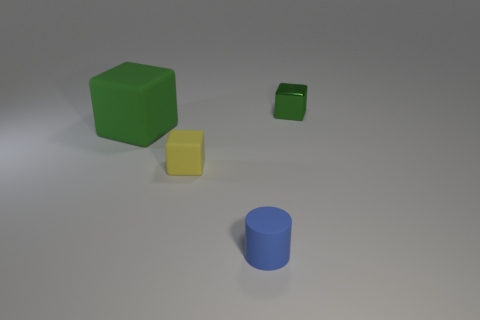Subtract all tiny shiny cubes. How many cubes are left? 2 Add 3 small brown cylinders. How many objects exist? 7 Subtract 0 cyan blocks. How many objects are left? 4 Subtract all blocks. How many objects are left? 1 Subtract 1 blocks. How many blocks are left? 2 Subtract all green blocks. Subtract all blue cylinders. How many blocks are left? 1 Subtract all purple spheres. How many green blocks are left? 2 Subtract all big things. Subtract all tiny red metallic spheres. How many objects are left? 3 Add 4 tiny rubber blocks. How many tiny rubber blocks are left? 5 Add 2 brown things. How many brown things exist? 2 